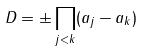Convert formula to latex. <formula><loc_0><loc_0><loc_500><loc_500>D = \pm \prod _ { j < k } ( a _ { j } - a _ { k } )</formula> 